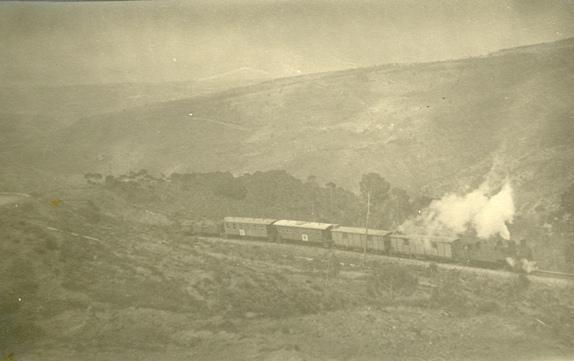How many people are wearing red vest?
Give a very brief answer. 0. 